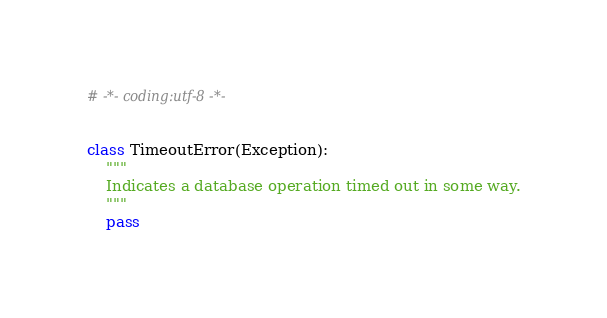<code> <loc_0><loc_0><loc_500><loc_500><_Python_># -*- coding:utf-8 -*-


class TimeoutError(Exception):
    """
    Indicates a database operation timed out in some way.
    """
    pass
</code> 